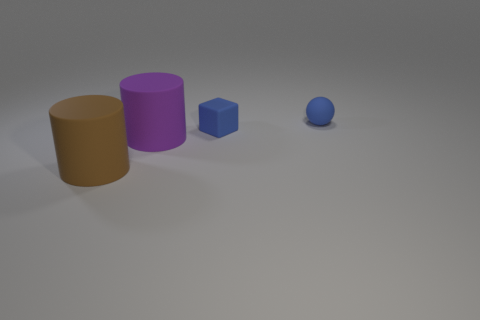How many other blocks have the same color as the tiny block?
Offer a very short reply. 0. Is the color of the cylinder that is in front of the purple matte cylinder the same as the tiny thing that is in front of the blue rubber ball?
Provide a short and direct response. No. There is a blue ball; are there any small blue balls on the right side of it?
Offer a very short reply. No. What is the material of the small block?
Keep it short and to the point. Rubber. The tiny blue object that is on the left side of the tiny blue ball has what shape?
Provide a short and direct response. Cube. The rubber thing that is the same color as the block is what size?
Your response must be concise. Small. Is there a blue object of the same size as the brown matte cylinder?
Provide a succinct answer. No. Does the tiny blue ball that is behind the small blue block have the same material as the purple cylinder?
Give a very brief answer. Yes. Are there an equal number of blue matte cubes that are in front of the big brown rubber object and big brown rubber cylinders on the right side of the tiny blue rubber sphere?
Offer a terse response. Yes. What is the shape of the matte object that is in front of the block and behind the big brown matte cylinder?
Your answer should be very brief. Cylinder. 